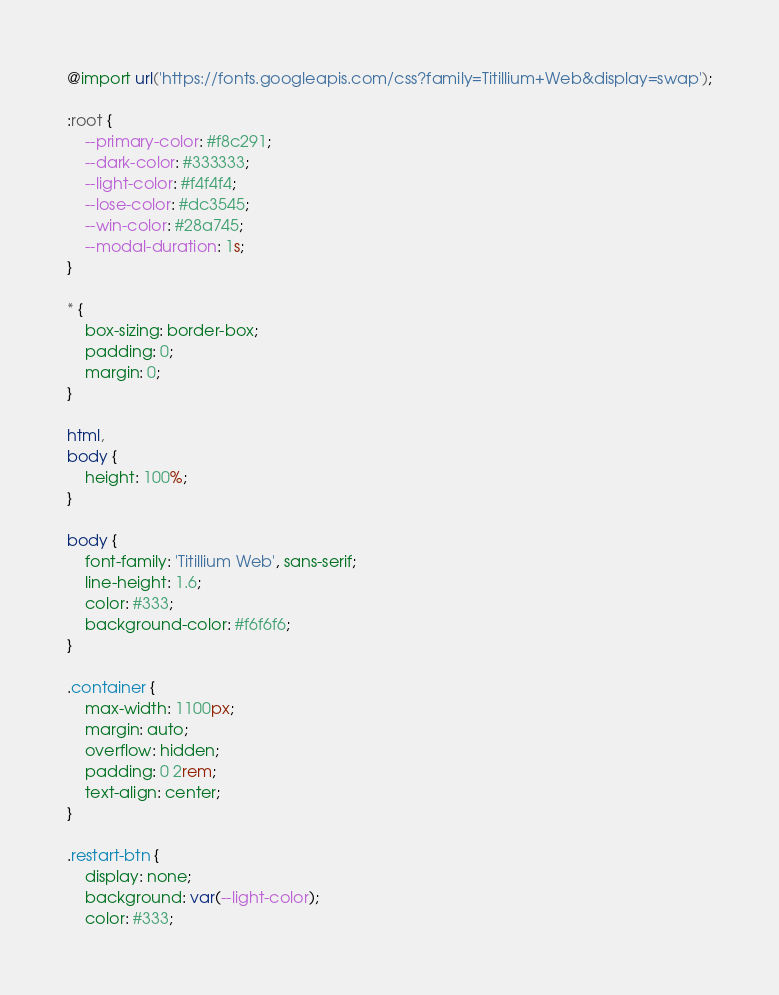Convert code to text. <code><loc_0><loc_0><loc_500><loc_500><_CSS_>@import url('https://fonts.googleapis.com/css?family=Titillium+Web&display=swap');

:root {
    --primary-color: #f8c291;
    --dark-color: #333333;
    --light-color: #f4f4f4;
    --lose-color: #dc3545;
    --win-color: #28a745;
    --modal-duration: 1s;
}

* {
    box-sizing: border-box;
    padding: 0;
    margin: 0;
}

html,
body {
    height: 100%;
}

body {
    font-family: 'Titillium Web', sans-serif;
    line-height: 1.6;
    color: #333;
    background-color: #f6f6f6;
}

.container {
    max-width: 1100px;
    margin: auto;
    overflow: hidden;
    padding: 0 2rem;
    text-align: center;
}

.restart-btn {
    display: none;
    background: var(--light-color);
    color: #333;</code> 